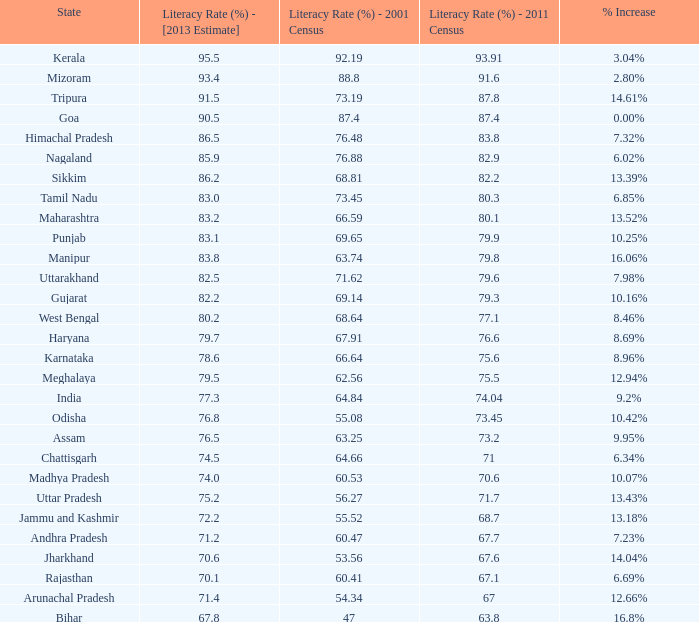81% in the 2001 86.2. 